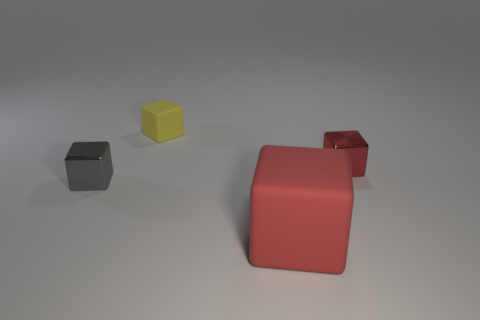Subtract 1 cubes. How many cubes are left? 3 Add 2 tiny gray metallic blocks. How many objects exist? 6 Add 3 tiny yellow cubes. How many tiny yellow cubes are left? 4 Add 4 tiny metallic blocks. How many tiny metallic blocks exist? 6 Subtract 0 blue spheres. How many objects are left? 4 Subtract all rubber blocks. Subtract all small purple cylinders. How many objects are left? 2 